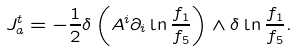<formula> <loc_0><loc_0><loc_500><loc_500>J _ { a } ^ { t } = - \frac { 1 } { 2 } \delta \left ( A ^ { i } \partial _ { i } \ln \frac { f _ { 1 } } { f _ { 5 } } \right ) \wedge \delta \ln \frac { f _ { 1 } } { f _ { 5 } } .</formula> 